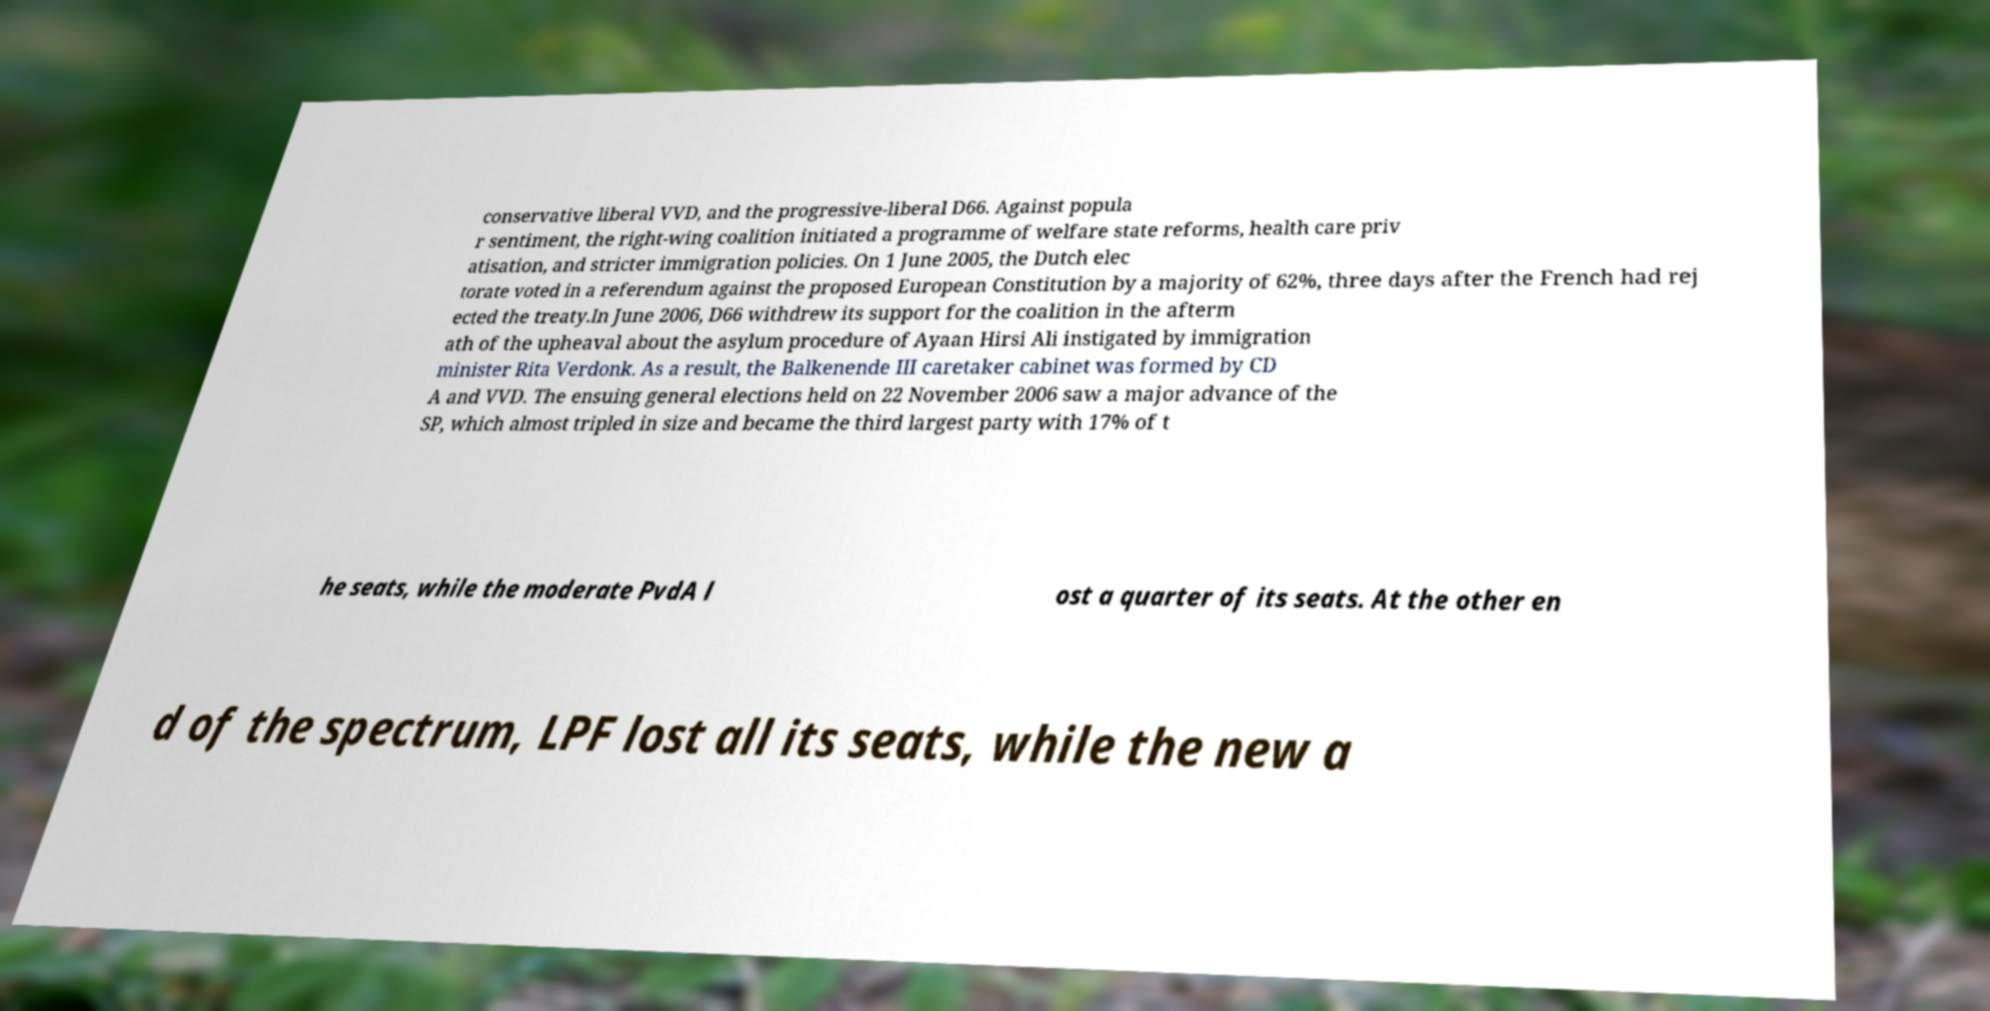Please identify and transcribe the text found in this image. conservative liberal VVD, and the progressive-liberal D66. Against popula r sentiment, the right-wing coalition initiated a programme of welfare state reforms, health care priv atisation, and stricter immigration policies. On 1 June 2005, the Dutch elec torate voted in a referendum against the proposed European Constitution by a majority of 62%, three days after the French had rej ected the treaty.In June 2006, D66 withdrew its support for the coalition in the afterm ath of the upheaval about the asylum procedure of Ayaan Hirsi Ali instigated by immigration minister Rita Verdonk. As a result, the Balkenende III caretaker cabinet was formed by CD A and VVD. The ensuing general elections held on 22 November 2006 saw a major advance of the SP, which almost tripled in size and became the third largest party with 17% of t he seats, while the moderate PvdA l ost a quarter of its seats. At the other en d of the spectrum, LPF lost all its seats, while the new a 